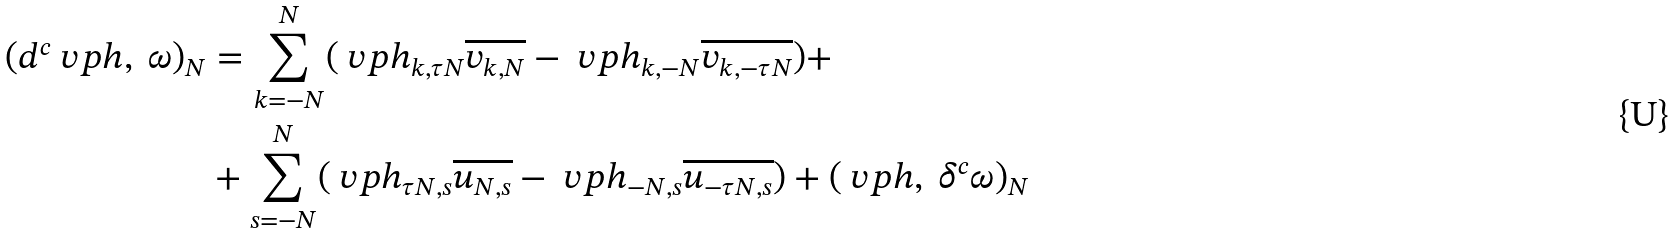<formula> <loc_0><loc_0><loc_500><loc_500>( d ^ { c } \ v p h , \ \omega ) _ { N } & = \sum _ { k = - N } ^ { N } ( \ v p h _ { k , \tau N } \overline { v _ { k , N } } - \ v p h _ { k , - N } \overline { v _ { k , - \tau N } } ) + \\ & + \sum _ { s = - N } ^ { N } ( \ v p h _ { \tau N , s } \overline { u _ { N , s } } - \ v p h _ { - N , s } \overline { u _ { - \tau N , s } } ) + ( \ v p h , \ \delta ^ { c } \omega ) _ { N }</formula> 